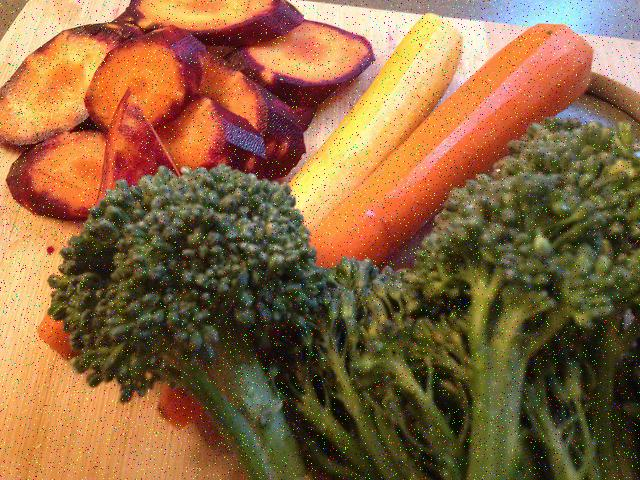Is the lighting in the image sufficient?
A. No
B. Yes
C. Dim and dark
Answer with the option's letter from the given choices directly.
 B. 